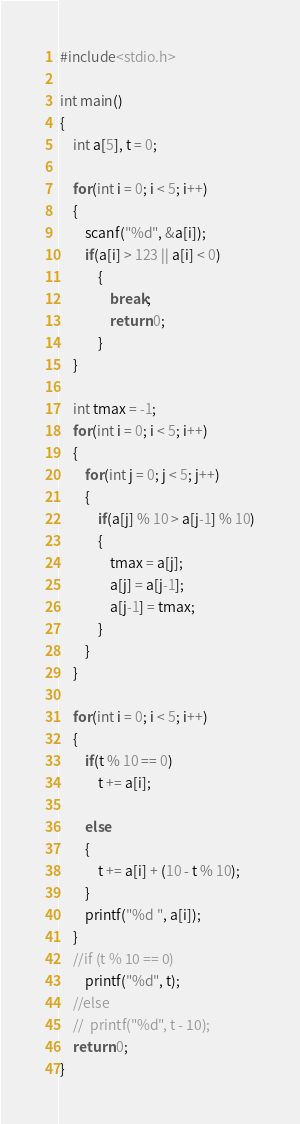Convert code to text. <code><loc_0><loc_0><loc_500><loc_500><_C_>#include<stdio.h>

int main()
{
	int a[5], t = 0;
	
	for(int i = 0; i < 5; i++)
	{
		scanf("%d", &a[i]);
		if(a[i] > 123 || a[i] < 0)
			{
				break;
				return 0;
			}
	} 

	int tmax = -1;
	for(int i = 0; i < 5; i++)
	{
		for(int j = 0; j < 5; j++)
		{
			if(a[j] % 10 > a[j-1] % 10)
			{
				tmax = a[j];
				a[j] = a[j-1];
				a[j-1] = tmax;
			}
		}
	}

	for(int i = 0; i < 5; i++)
	{
		if(t % 10 == 0)
			t += a[i];
		
		else
		{
			t += a[i] + (10 - t % 10);
		}
		printf("%d ", a[i]);
	}
	//if (t % 10 == 0)
		printf("%d", t);
	//else
	//	printf("%d", t - 10);
	return 0;
}
</code> 